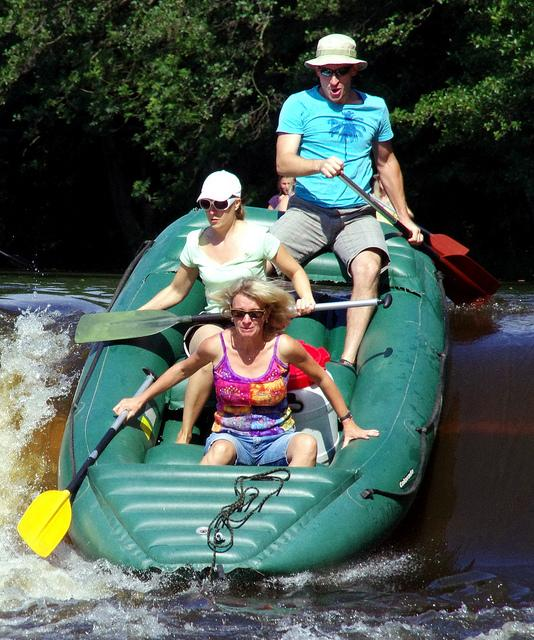What type of boat are they navigating the water on? Please explain your reasoning. raft. This is a big raft 